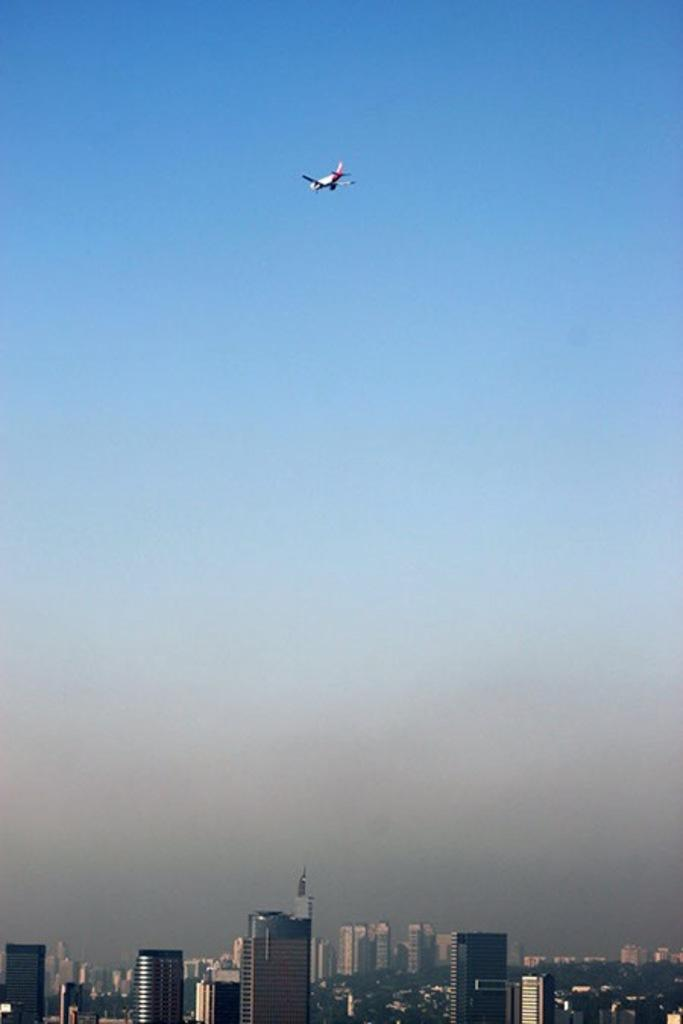What type of structures are located at the bottom of the image? There are buildings at the bottom of the image. What can be seen in the background of the image? The sky is visible in the background of the image. What is located at the top of the image? There is an airplane at the top of the image. Are there any mines visible in the image? There are no mines present in the image. Can you see any crows in the image? There are no crows present in the image. 